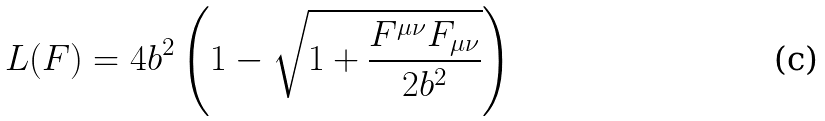<formula> <loc_0><loc_0><loc_500><loc_500>L ( F ) = 4 b ^ { 2 } \left ( 1 - \sqrt { 1 + \frac { F ^ { \mu \nu } F _ { \mu \nu } } { 2 b ^ { 2 } } } \right )</formula> 